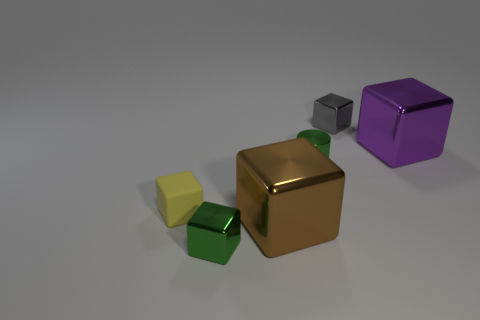Do the tiny metallic object that is in front of the cylinder and the shiny cylinder have the same color?
Your answer should be very brief. Yes. How many other objects are there of the same color as the tiny rubber object?
Your answer should be compact. 0. What number of big objects are green blocks or cyan metal cylinders?
Your answer should be very brief. 0. Are there more large brown objects than big cyan rubber cubes?
Give a very brief answer. Yes. Is the green cylinder made of the same material as the purple cube?
Your response must be concise. Yes. Is there anything else that is made of the same material as the small yellow object?
Offer a very short reply. No. Is the number of tiny things that are in front of the large purple metal cube greater than the number of big yellow metallic cylinders?
Provide a short and direct response. Yes. How many small gray metal things have the same shape as the purple metal thing?
Your answer should be very brief. 1. There is a brown block that is the same material as the cylinder; what is its size?
Ensure brevity in your answer.  Large. The small metal object that is both behind the tiny green block and in front of the gray metal thing is what color?
Offer a terse response. Green. 